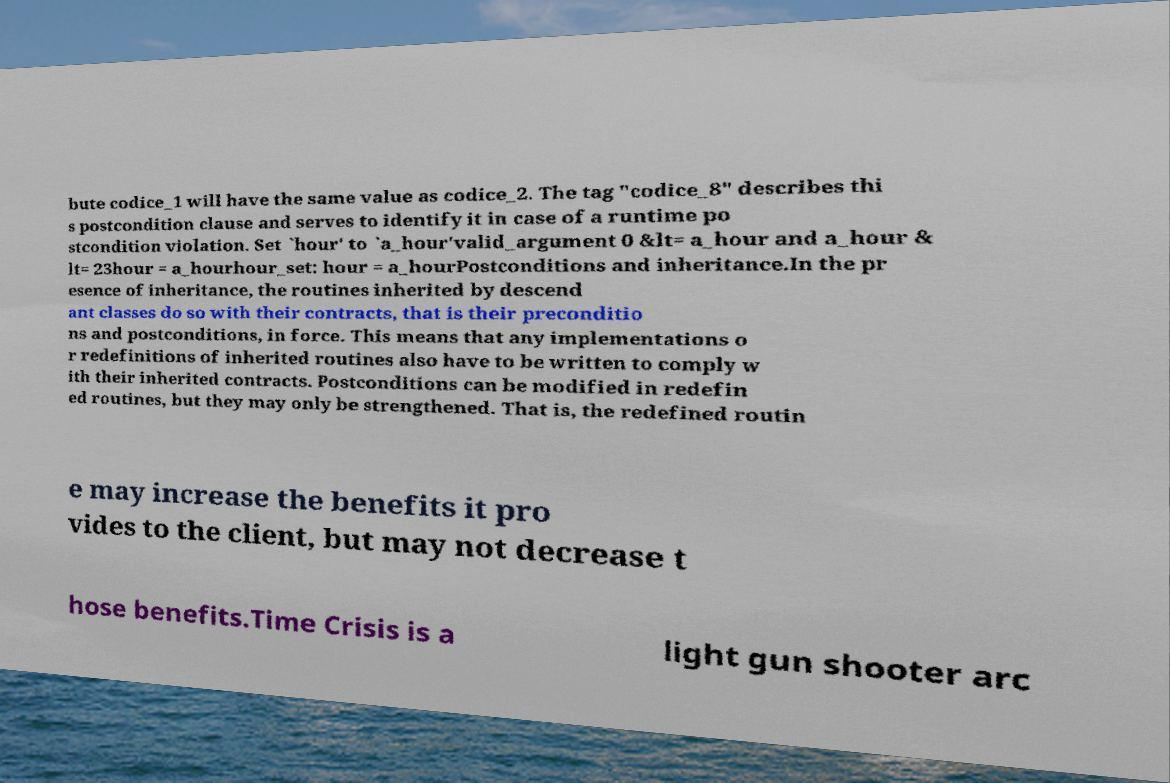Could you extract and type out the text from this image? bute codice_1 will have the same value as codice_2. The tag "codice_8" describes thi s postcondition clause and serves to identify it in case of a runtime po stcondition violation. Set `hour' to `a_hour'valid_argument 0 &lt= a_hour and a_hour & lt= 23hour = a_hourhour_set: hour = a_hourPostconditions and inheritance.In the pr esence of inheritance, the routines inherited by descend ant classes do so with their contracts, that is their preconditio ns and postconditions, in force. This means that any implementations o r redefinitions of inherited routines also have to be written to comply w ith their inherited contracts. Postconditions can be modified in redefin ed routines, but they may only be strengthened. That is, the redefined routin e may increase the benefits it pro vides to the client, but may not decrease t hose benefits.Time Crisis is a light gun shooter arc 